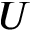<formula> <loc_0><loc_0><loc_500><loc_500>U</formula> 